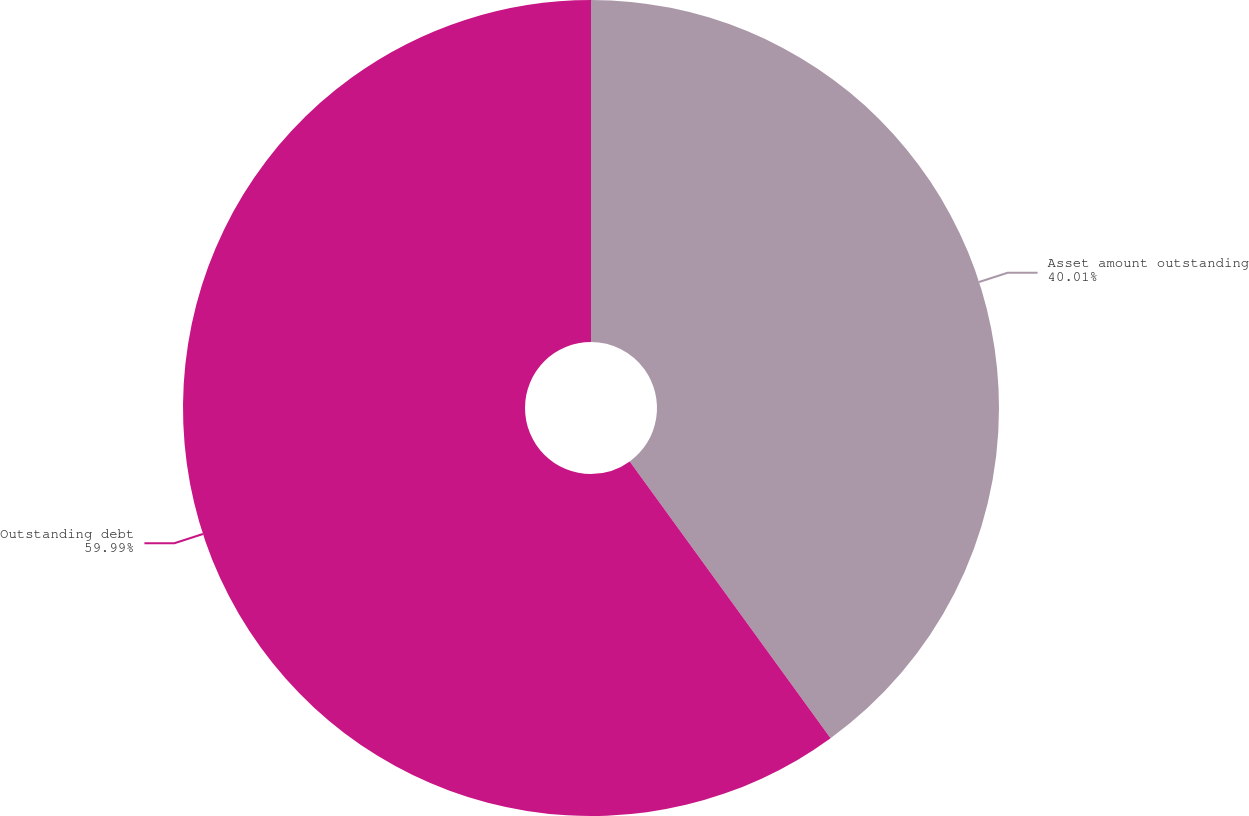Convert chart. <chart><loc_0><loc_0><loc_500><loc_500><pie_chart><fcel>Asset amount outstanding<fcel>Outstanding debt<nl><fcel>40.01%<fcel>59.99%<nl></chart> 